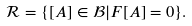<formula> <loc_0><loc_0><loc_500><loc_500>\mathcal { R } = \{ [ A ] \in \mathcal { B | } F [ A ] = 0 \} .</formula> 